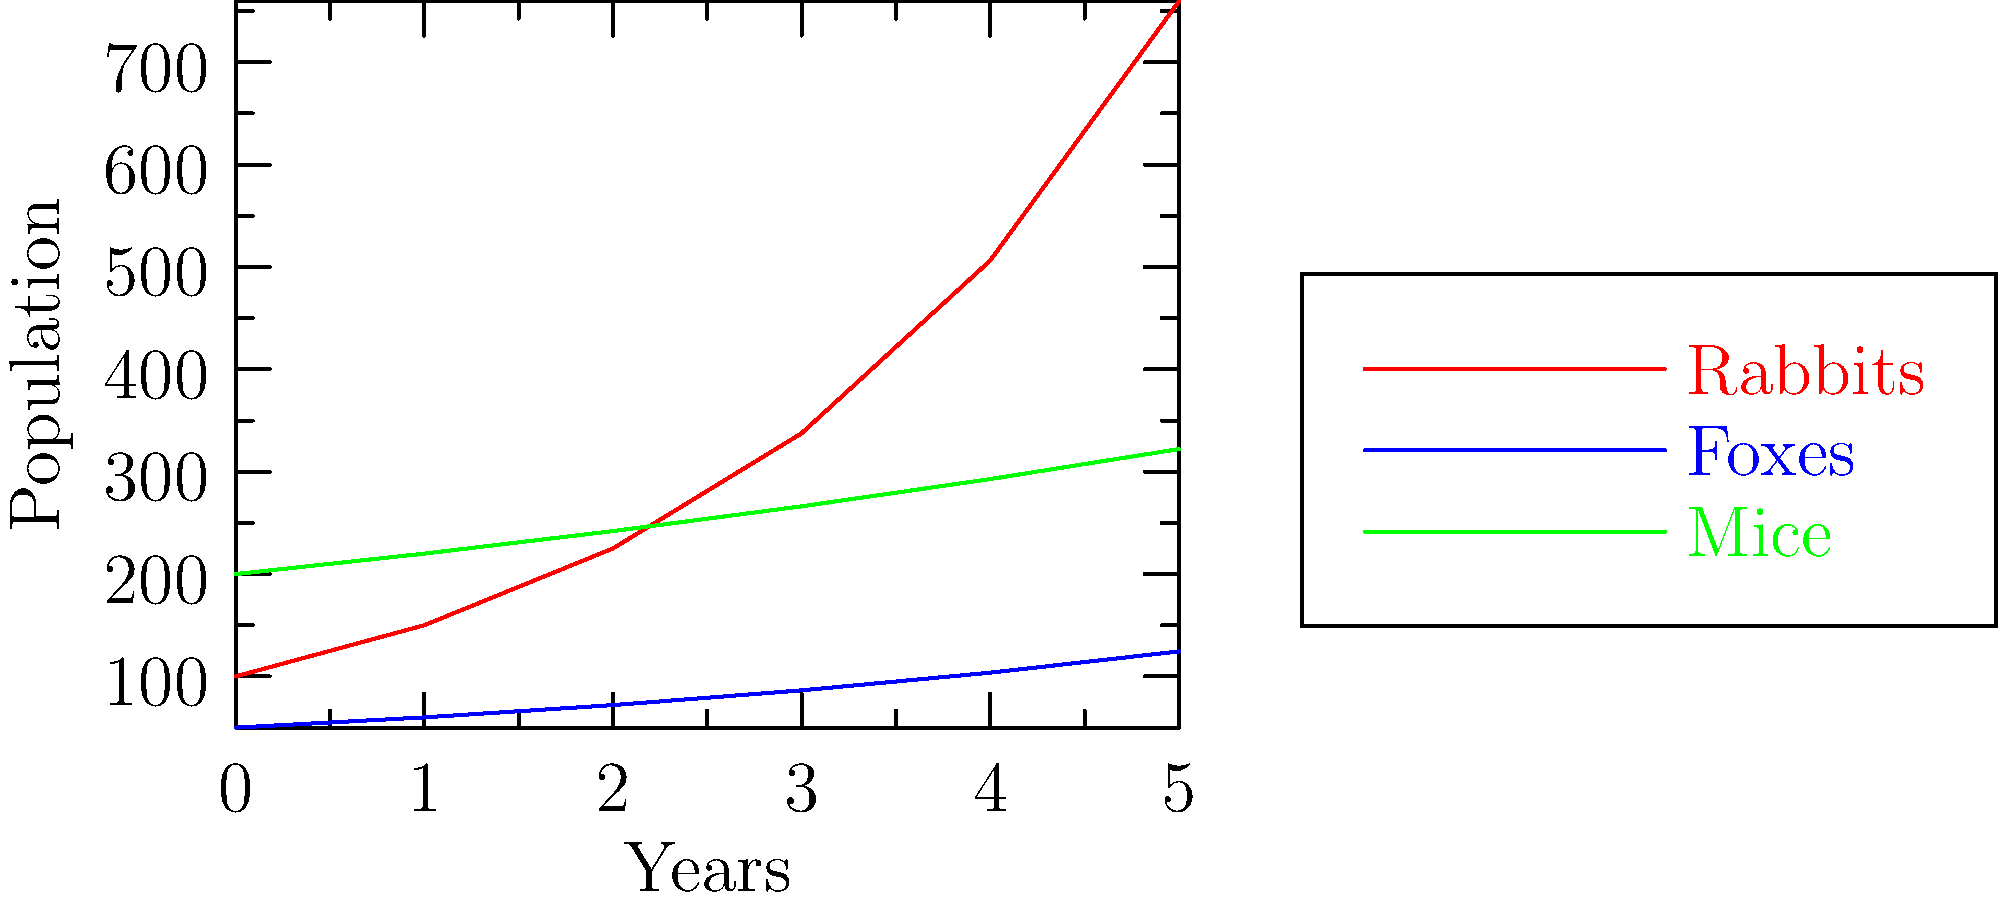Based on the line graph showing population growth rates of rabbits, foxes, and mice over 5 years, which species exhibits the highest exponential growth rate? Provide a brief explanation for your choice, considering the skeptical nature of the observer. To determine the species with the highest exponential growth rate, we need to analyze the steepness and curvature of each line:

1. Rabbits (red line):
   - Shows the steepest curve
   - Population increases rapidly from 100 to 759.375 in 5 years
   - Clear exponential growth pattern

2. Foxes (blue line):
   - Moderate growth
   - Population increases from 50 to 124.416 in 5 years
   - Appears more linear than exponential

3. Mice (green line):
   - Slowest growth
   - Population increases from 200 to 322.102 in 5 years
   - Almost linear growth

The rabbit population shows the most dramatic increase and the most pronounced curvature, indicating the highest exponential growth rate. We can verify this by calculating the growth rate:

Rabbits: $\frac{759.375}{100} \approx 7.59$ (659% increase)
Foxes: $\frac{124.416}{50} \approx 2.49$ (149% increase)
Mice: $\frac{322.102}{200} \approx 1.61$ (61% increase)

For a skeptical observer, it's important to note that this is based solely on the given data and assumes consistent growth patterns, which may not always be the case in real-world scenarios due to various environmental factors.
Answer: Rabbits have the highest exponential growth rate. 